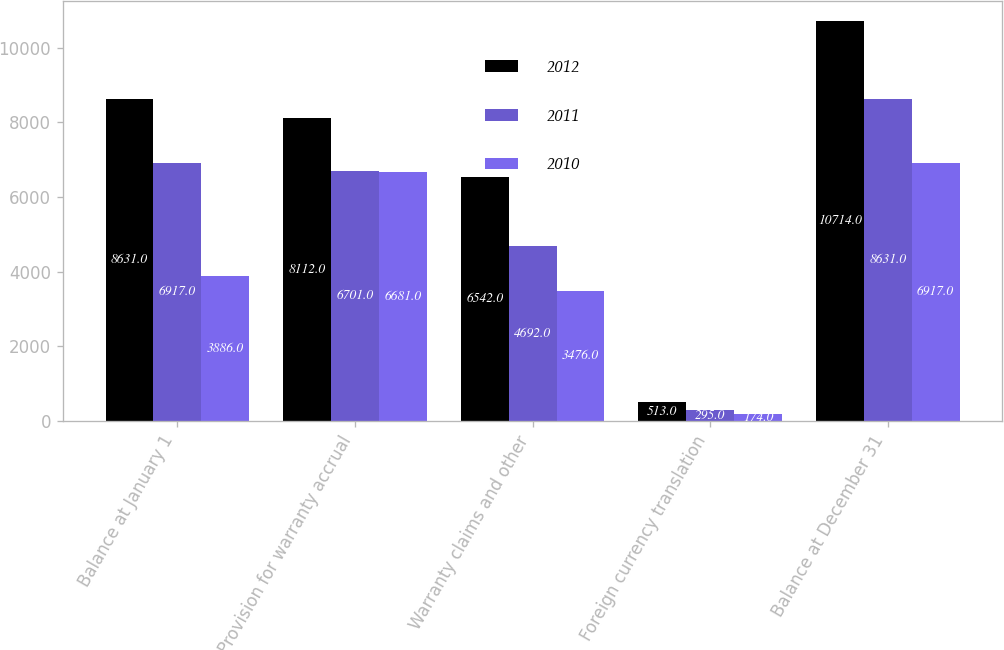<chart> <loc_0><loc_0><loc_500><loc_500><stacked_bar_chart><ecel><fcel>Balance at January 1<fcel>Provision for warranty accrual<fcel>Warranty claims and other<fcel>Foreign currency translation<fcel>Balance at December 31<nl><fcel>2012<fcel>8631<fcel>8112<fcel>6542<fcel>513<fcel>10714<nl><fcel>2011<fcel>6917<fcel>6701<fcel>4692<fcel>295<fcel>8631<nl><fcel>2010<fcel>3886<fcel>6681<fcel>3476<fcel>174<fcel>6917<nl></chart> 